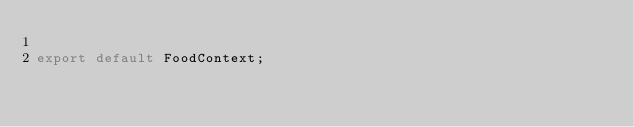Convert code to text. <code><loc_0><loc_0><loc_500><loc_500><_JavaScript_>
export default FoodContext;
</code> 